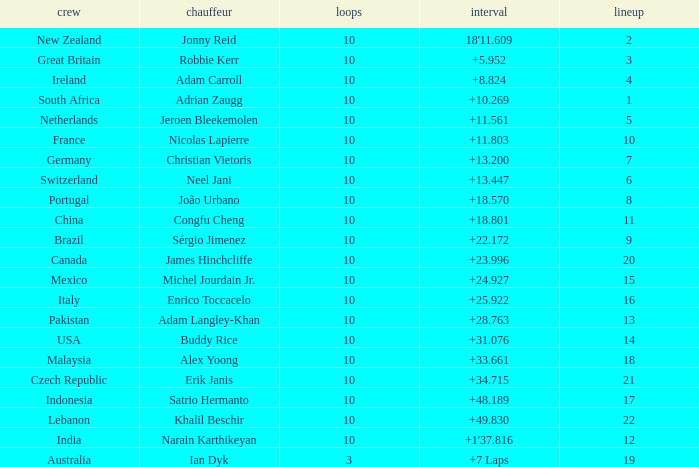What team had 10 Labs and the Driver was Alex Yoong? Malaysia. 